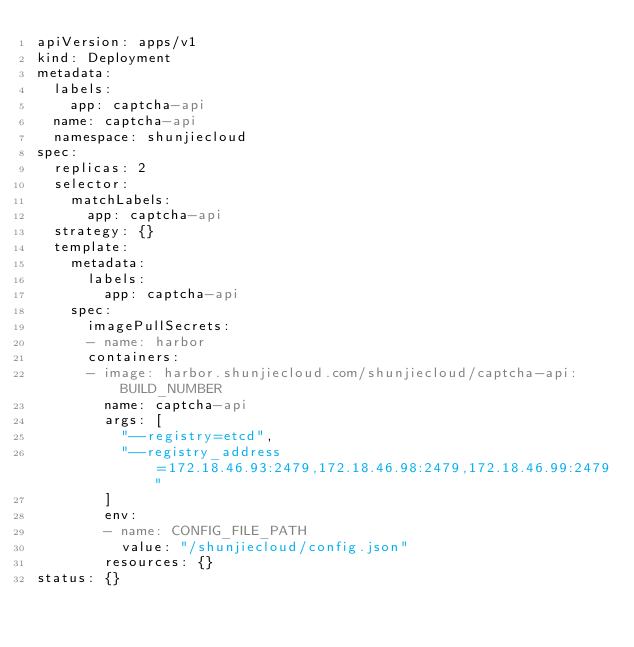<code> <loc_0><loc_0><loc_500><loc_500><_YAML_>apiVersion: apps/v1
kind: Deployment
metadata:
  labels:
    app: captcha-api
  name: captcha-api
  namespace: shunjiecloud
spec:
  replicas: 2
  selector:
    matchLabels:
      app: captcha-api
  strategy: {}
  template:
    metadata:
      labels:
        app: captcha-api
    spec:
      imagePullSecrets:
      - name: harbor
      containers:
      - image: harbor.shunjiecloud.com/shunjiecloud/captcha-api:BUILD_NUMBER
        name: captcha-api
        args: [
          "--registry=etcd",
          "--registry_address=172.18.46.93:2479,172.18.46.98:2479,172.18.46.99:2479"
        ]
        env:
        - name: CONFIG_FILE_PATH
          value: "/shunjiecloud/config.json"
        resources: {}
status: {}</code> 